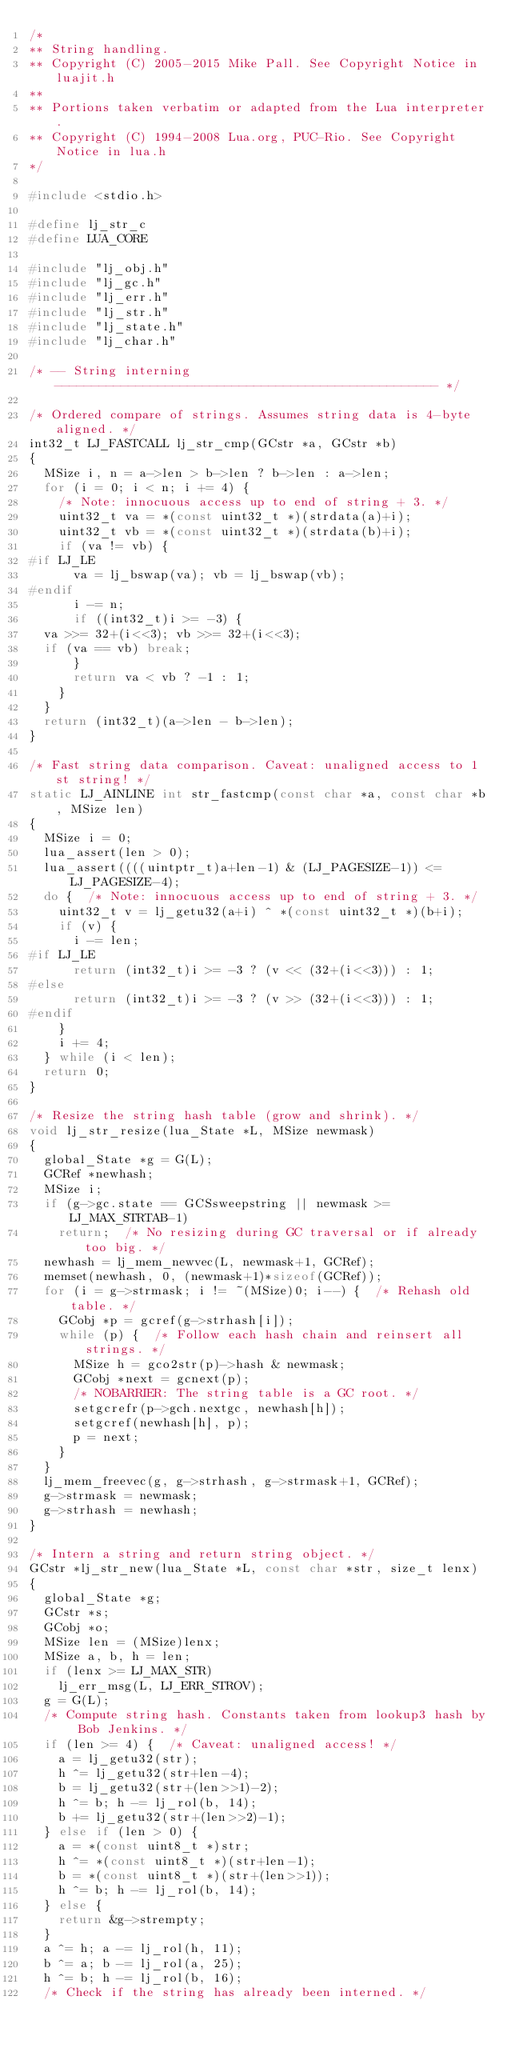Convert code to text. <code><loc_0><loc_0><loc_500><loc_500><_C_>/*
** String handling.
** Copyright (C) 2005-2015 Mike Pall. See Copyright Notice in luajit.h
**
** Portions taken verbatim or adapted from the Lua interpreter.
** Copyright (C) 1994-2008 Lua.org, PUC-Rio. See Copyright Notice in lua.h
*/

#include <stdio.h>

#define lj_str_c
#define LUA_CORE

#include "lj_obj.h"
#include "lj_gc.h"
#include "lj_err.h"
#include "lj_str.h"
#include "lj_state.h"
#include "lj_char.h"

/* -- String interning ---------------------------------------------------- */

/* Ordered compare of strings. Assumes string data is 4-byte aligned. */
int32_t LJ_FASTCALL lj_str_cmp(GCstr *a, GCstr *b)
{
  MSize i, n = a->len > b->len ? b->len : a->len;
  for (i = 0; i < n; i += 4) {
    /* Note: innocuous access up to end of string + 3. */
    uint32_t va = *(const uint32_t *)(strdata(a)+i);
    uint32_t vb = *(const uint32_t *)(strdata(b)+i);
    if (va != vb) {
#if LJ_LE
      va = lj_bswap(va); vb = lj_bswap(vb);
#endif
      i -= n;
      if ((int32_t)i >= -3) {
	va >>= 32+(i<<3); vb >>= 32+(i<<3);
	if (va == vb) break;
      }
      return va < vb ? -1 : 1;
    }
  }
  return (int32_t)(a->len - b->len);
}

/* Fast string data comparison. Caveat: unaligned access to 1st string! */
static LJ_AINLINE int str_fastcmp(const char *a, const char *b, MSize len)
{
  MSize i = 0;
  lua_assert(len > 0);
  lua_assert((((uintptr_t)a+len-1) & (LJ_PAGESIZE-1)) <= LJ_PAGESIZE-4);
  do {  /* Note: innocuous access up to end of string + 3. */
    uint32_t v = lj_getu32(a+i) ^ *(const uint32_t *)(b+i);
    if (v) {
      i -= len;
#if LJ_LE
      return (int32_t)i >= -3 ? (v << (32+(i<<3))) : 1;
#else
      return (int32_t)i >= -3 ? (v >> (32+(i<<3))) : 1;
#endif
    }
    i += 4;
  } while (i < len);
  return 0;
}

/* Resize the string hash table (grow and shrink). */
void lj_str_resize(lua_State *L, MSize newmask)
{
  global_State *g = G(L);
  GCRef *newhash;
  MSize i;
  if (g->gc.state == GCSsweepstring || newmask >= LJ_MAX_STRTAB-1)
    return;  /* No resizing during GC traversal or if already too big. */
  newhash = lj_mem_newvec(L, newmask+1, GCRef);
  memset(newhash, 0, (newmask+1)*sizeof(GCRef));
  for (i = g->strmask; i != ~(MSize)0; i--) {  /* Rehash old table. */
    GCobj *p = gcref(g->strhash[i]);
    while (p) {  /* Follow each hash chain and reinsert all strings. */
      MSize h = gco2str(p)->hash & newmask;
      GCobj *next = gcnext(p);
      /* NOBARRIER: The string table is a GC root. */
      setgcrefr(p->gch.nextgc, newhash[h]);
      setgcref(newhash[h], p);
      p = next;
    }
  }
  lj_mem_freevec(g, g->strhash, g->strmask+1, GCRef);
  g->strmask = newmask;
  g->strhash = newhash;
}

/* Intern a string and return string object. */
GCstr *lj_str_new(lua_State *L, const char *str, size_t lenx)
{
  global_State *g;
  GCstr *s;
  GCobj *o;
  MSize len = (MSize)lenx;
  MSize a, b, h = len;
  if (lenx >= LJ_MAX_STR)
    lj_err_msg(L, LJ_ERR_STROV);
  g = G(L);
  /* Compute string hash. Constants taken from lookup3 hash by Bob Jenkins. */
  if (len >= 4) {  /* Caveat: unaligned access! */
    a = lj_getu32(str);
    h ^= lj_getu32(str+len-4);
    b = lj_getu32(str+(len>>1)-2);
    h ^= b; h -= lj_rol(b, 14);
    b += lj_getu32(str+(len>>2)-1);
  } else if (len > 0) {
    a = *(const uint8_t *)str;
    h ^= *(const uint8_t *)(str+len-1);
    b = *(const uint8_t *)(str+(len>>1));
    h ^= b; h -= lj_rol(b, 14);
  } else {
    return &g->strempty;
  }
  a ^= h; a -= lj_rol(h, 11);
  b ^= a; b -= lj_rol(a, 25);
  h ^= b; h -= lj_rol(b, 16);
  /* Check if the string has already been interned. */</code> 